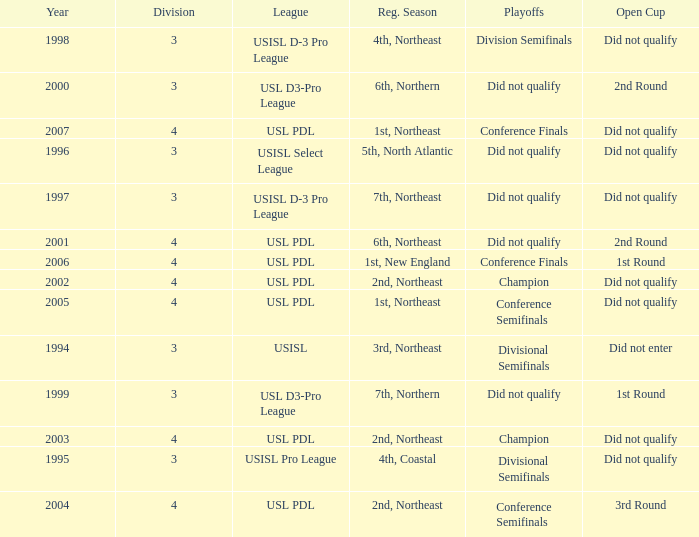Name the number of playoffs for 3rd round 1.0. 